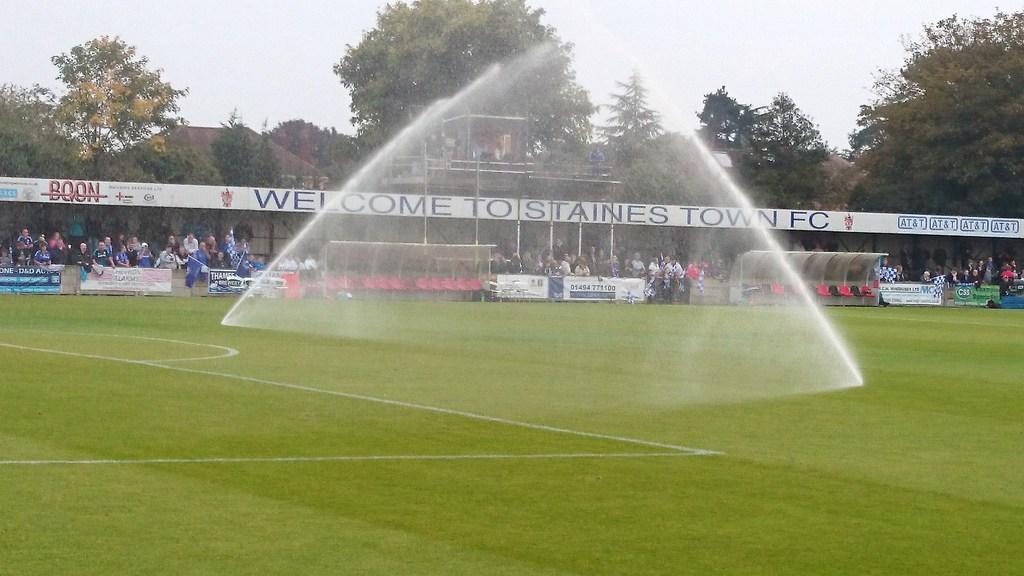What does the red word say on the side?
Ensure brevity in your answer.  Boon. Where does the signs say welcome too?
Offer a terse response. Staines town fc. 